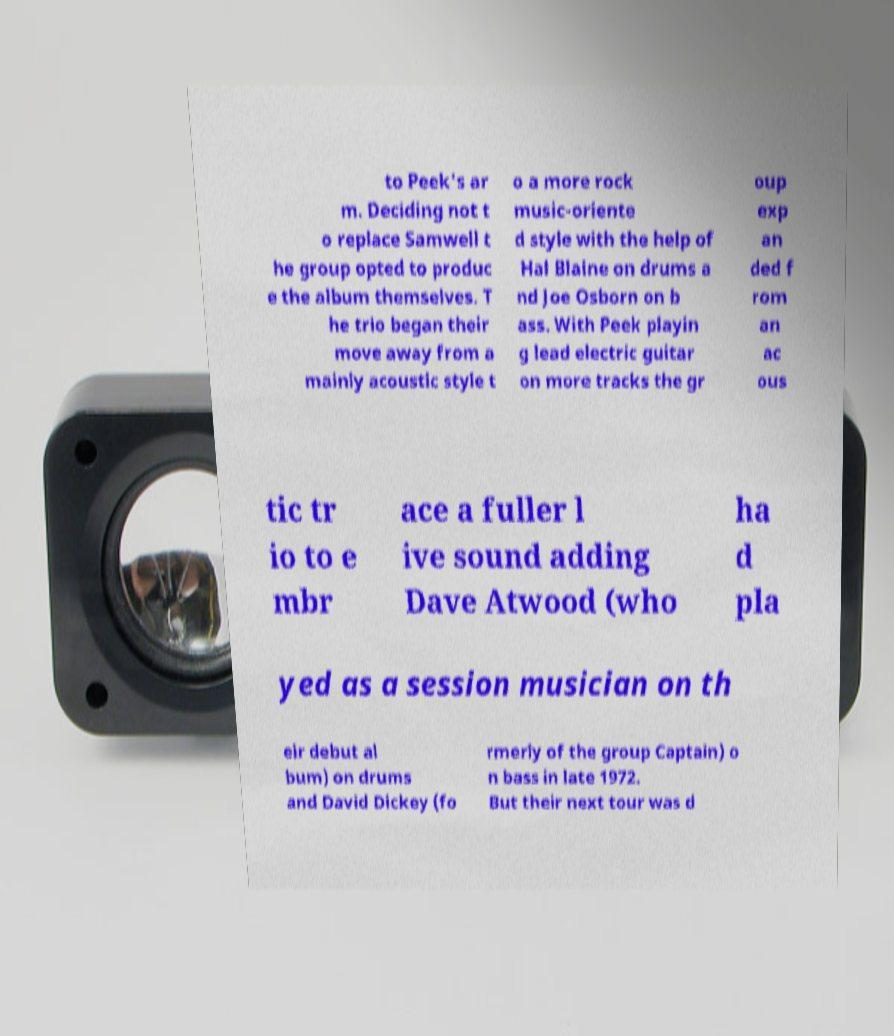Please read and relay the text visible in this image. What does it say? to Peek's ar m. Deciding not t o replace Samwell t he group opted to produc e the album themselves. T he trio began their move away from a mainly acoustic style t o a more rock music-oriente d style with the help of Hal Blaine on drums a nd Joe Osborn on b ass. With Peek playin g lead electric guitar on more tracks the gr oup exp an ded f rom an ac ous tic tr io to e mbr ace a fuller l ive sound adding Dave Atwood (who ha d pla yed as a session musician on th eir debut al bum) on drums and David Dickey (fo rmerly of the group Captain) o n bass in late 1972. But their next tour was d 